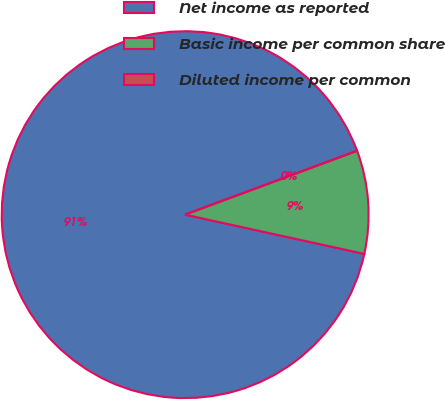Convert chart to OTSL. <chart><loc_0><loc_0><loc_500><loc_500><pie_chart><fcel>Net income as reported<fcel>Basic income per common share<fcel>Diluted income per common<nl><fcel>90.91%<fcel>9.09%<fcel>0.0%<nl></chart> 